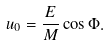Convert formula to latex. <formula><loc_0><loc_0><loc_500><loc_500>u _ { 0 } = \frac { E } { M } \cos \Phi .</formula> 